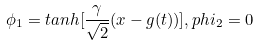Convert formula to latex. <formula><loc_0><loc_0><loc_500><loc_500>\phi _ { 1 } = t a n h [ \frac { \gamma } { \sqrt { 2 } } ( x - g ( t ) ) ] , p h i _ { 2 } = 0</formula> 